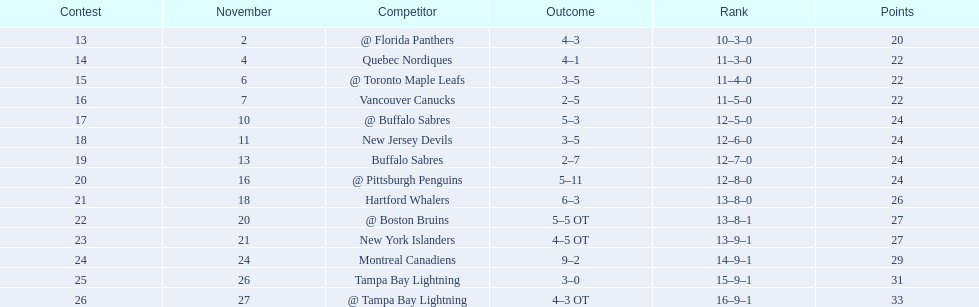Were the new jersey devils in last place according to the chart? No. 